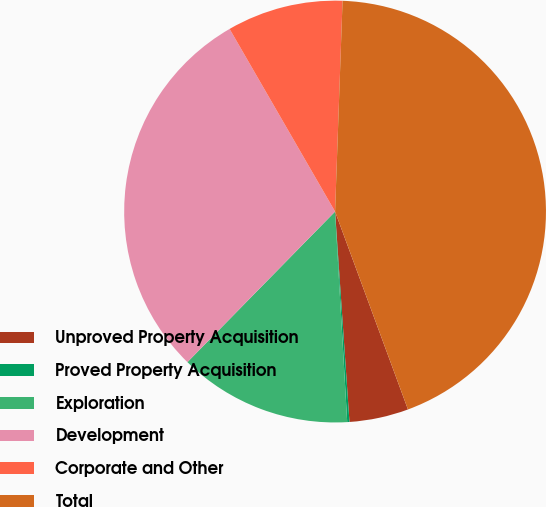Convert chart to OTSL. <chart><loc_0><loc_0><loc_500><loc_500><pie_chart><fcel>Unproved Property Acquisition<fcel>Proved Property Acquisition<fcel>Exploration<fcel>Development<fcel>Corporate and Other<fcel>Total<nl><fcel>4.53%<fcel>0.17%<fcel>13.26%<fcel>29.32%<fcel>8.9%<fcel>43.82%<nl></chart> 